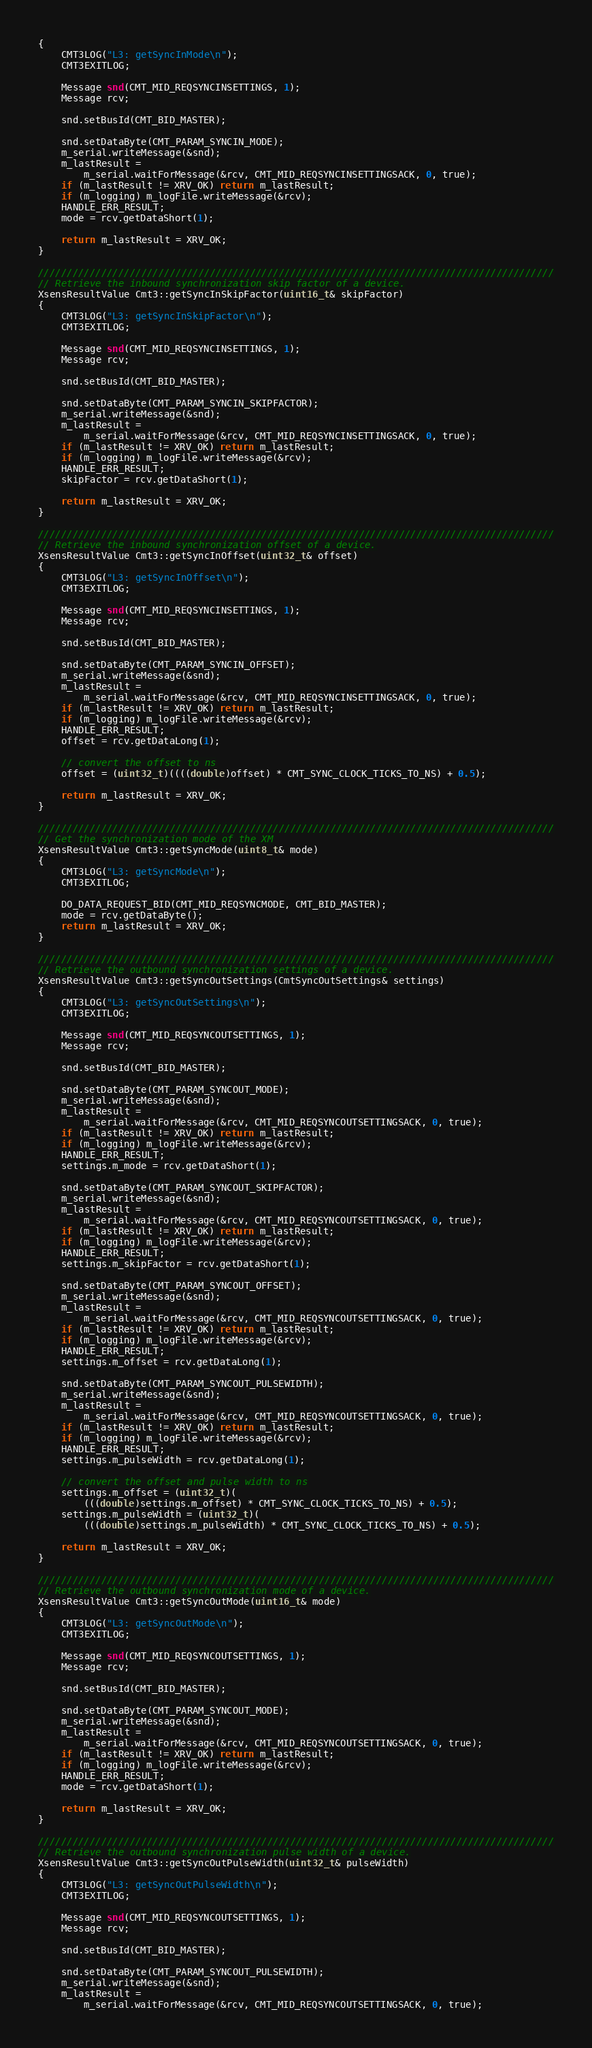<code> <loc_0><loc_0><loc_500><loc_500><_C++_>{
	CMT3LOG("L3: getSyncInMode\n");
	CMT3EXITLOG;

	Message snd(CMT_MID_REQSYNCINSETTINGS, 1);
	Message rcv;

	snd.setBusId(CMT_BID_MASTER);

	snd.setDataByte(CMT_PARAM_SYNCIN_MODE);
	m_serial.writeMessage(&snd);
	m_lastResult =
		m_serial.waitForMessage(&rcv, CMT_MID_REQSYNCINSETTINGSACK, 0, true);
	if (m_lastResult != XRV_OK) return m_lastResult;
	if (m_logging) m_logFile.writeMessage(&rcv);
	HANDLE_ERR_RESULT;
	mode = rcv.getDataShort(1);

	return m_lastResult = XRV_OK;
}

//////////////////////////////////////////////////////////////////////////////////////////
// Retrieve the inbound synchronization skip factor of a device.
XsensResultValue Cmt3::getSyncInSkipFactor(uint16_t& skipFactor)
{
	CMT3LOG("L3: getSyncInSkipFactor\n");
	CMT3EXITLOG;

	Message snd(CMT_MID_REQSYNCINSETTINGS, 1);
	Message rcv;

	snd.setBusId(CMT_BID_MASTER);

	snd.setDataByte(CMT_PARAM_SYNCIN_SKIPFACTOR);
	m_serial.writeMessage(&snd);
	m_lastResult =
		m_serial.waitForMessage(&rcv, CMT_MID_REQSYNCINSETTINGSACK, 0, true);
	if (m_lastResult != XRV_OK) return m_lastResult;
	if (m_logging) m_logFile.writeMessage(&rcv);
	HANDLE_ERR_RESULT;
	skipFactor = rcv.getDataShort(1);

	return m_lastResult = XRV_OK;
}

//////////////////////////////////////////////////////////////////////////////////////////
// Retrieve the inbound synchronization offset of a device.
XsensResultValue Cmt3::getSyncInOffset(uint32_t& offset)
{
	CMT3LOG("L3: getSyncInOffset\n");
	CMT3EXITLOG;

	Message snd(CMT_MID_REQSYNCINSETTINGS, 1);
	Message rcv;

	snd.setBusId(CMT_BID_MASTER);

	snd.setDataByte(CMT_PARAM_SYNCIN_OFFSET);
	m_serial.writeMessage(&snd);
	m_lastResult =
		m_serial.waitForMessage(&rcv, CMT_MID_REQSYNCINSETTINGSACK, 0, true);
	if (m_lastResult != XRV_OK) return m_lastResult;
	if (m_logging) m_logFile.writeMessage(&rcv);
	HANDLE_ERR_RESULT;
	offset = rcv.getDataLong(1);

	// convert the offset to ns
	offset = (uint32_t)((((double)offset) * CMT_SYNC_CLOCK_TICKS_TO_NS) + 0.5);

	return m_lastResult = XRV_OK;
}

//////////////////////////////////////////////////////////////////////////////////////////
// Get the synchronization mode of the XM
XsensResultValue Cmt3::getSyncMode(uint8_t& mode)
{
	CMT3LOG("L3: getSyncMode\n");
	CMT3EXITLOG;

	DO_DATA_REQUEST_BID(CMT_MID_REQSYNCMODE, CMT_BID_MASTER);
	mode = rcv.getDataByte();
	return m_lastResult = XRV_OK;
}

//////////////////////////////////////////////////////////////////////////////////////////
// Retrieve the outbound synchronization settings of a device.
XsensResultValue Cmt3::getSyncOutSettings(CmtSyncOutSettings& settings)
{
	CMT3LOG("L3: getSyncOutSettings\n");
	CMT3EXITLOG;

	Message snd(CMT_MID_REQSYNCOUTSETTINGS, 1);
	Message rcv;

	snd.setBusId(CMT_BID_MASTER);

	snd.setDataByte(CMT_PARAM_SYNCOUT_MODE);
	m_serial.writeMessage(&snd);
	m_lastResult =
		m_serial.waitForMessage(&rcv, CMT_MID_REQSYNCOUTSETTINGSACK, 0, true);
	if (m_lastResult != XRV_OK) return m_lastResult;
	if (m_logging) m_logFile.writeMessage(&rcv);
	HANDLE_ERR_RESULT;
	settings.m_mode = rcv.getDataShort(1);

	snd.setDataByte(CMT_PARAM_SYNCOUT_SKIPFACTOR);
	m_serial.writeMessage(&snd);
	m_lastResult =
		m_serial.waitForMessage(&rcv, CMT_MID_REQSYNCOUTSETTINGSACK, 0, true);
	if (m_lastResult != XRV_OK) return m_lastResult;
	if (m_logging) m_logFile.writeMessage(&rcv);
	HANDLE_ERR_RESULT;
	settings.m_skipFactor = rcv.getDataShort(1);

	snd.setDataByte(CMT_PARAM_SYNCOUT_OFFSET);
	m_serial.writeMessage(&snd);
	m_lastResult =
		m_serial.waitForMessage(&rcv, CMT_MID_REQSYNCOUTSETTINGSACK, 0, true);
	if (m_lastResult != XRV_OK) return m_lastResult;
	if (m_logging) m_logFile.writeMessage(&rcv);
	HANDLE_ERR_RESULT;
	settings.m_offset = rcv.getDataLong(1);

	snd.setDataByte(CMT_PARAM_SYNCOUT_PULSEWIDTH);
	m_serial.writeMessage(&snd);
	m_lastResult =
		m_serial.waitForMessage(&rcv, CMT_MID_REQSYNCOUTSETTINGSACK, 0, true);
	if (m_lastResult != XRV_OK) return m_lastResult;
	if (m_logging) m_logFile.writeMessage(&rcv);
	HANDLE_ERR_RESULT;
	settings.m_pulseWidth = rcv.getDataLong(1);

	// convert the offset and pulse width to ns
	settings.m_offset = (uint32_t)(
		(((double)settings.m_offset) * CMT_SYNC_CLOCK_TICKS_TO_NS) + 0.5);
	settings.m_pulseWidth = (uint32_t)(
		(((double)settings.m_pulseWidth) * CMT_SYNC_CLOCK_TICKS_TO_NS) + 0.5);

	return m_lastResult = XRV_OK;
}

//////////////////////////////////////////////////////////////////////////////////////////
// Retrieve the outbound synchronization mode of a device.
XsensResultValue Cmt3::getSyncOutMode(uint16_t& mode)
{
	CMT3LOG("L3: getSyncOutMode\n");
	CMT3EXITLOG;

	Message snd(CMT_MID_REQSYNCOUTSETTINGS, 1);
	Message rcv;

	snd.setBusId(CMT_BID_MASTER);

	snd.setDataByte(CMT_PARAM_SYNCOUT_MODE);
	m_serial.writeMessage(&snd);
	m_lastResult =
		m_serial.waitForMessage(&rcv, CMT_MID_REQSYNCOUTSETTINGSACK, 0, true);
	if (m_lastResult != XRV_OK) return m_lastResult;
	if (m_logging) m_logFile.writeMessage(&rcv);
	HANDLE_ERR_RESULT;
	mode = rcv.getDataShort(1);

	return m_lastResult = XRV_OK;
}

//////////////////////////////////////////////////////////////////////////////////////////
// Retrieve the outbound synchronization pulse width of a device.
XsensResultValue Cmt3::getSyncOutPulseWidth(uint32_t& pulseWidth)
{
	CMT3LOG("L3: getSyncOutPulseWidth\n");
	CMT3EXITLOG;

	Message snd(CMT_MID_REQSYNCOUTSETTINGS, 1);
	Message rcv;

	snd.setBusId(CMT_BID_MASTER);

	snd.setDataByte(CMT_PARAM_SYNCOUT_PULSEWIDTH);
	m_serial.writeMessage(&snd);
	m_lastResult =
		m_serial.waitForMessage(&rcv, CMT_MID_REQSYNCOUTSETTINGSACK, 0, true);</code> 